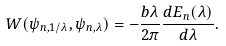Convert formula to latex. <formula><loc_0><loc_0><loc_500><loc_500>W ( \psi _ { n , 1 / \lambda } , \psi _ { n , \lambda } ) = - \frac { b \lambda } { 2 \pi } \frac { d E _ { n } ( \lambda ) } { d \lambda } .</formula> 